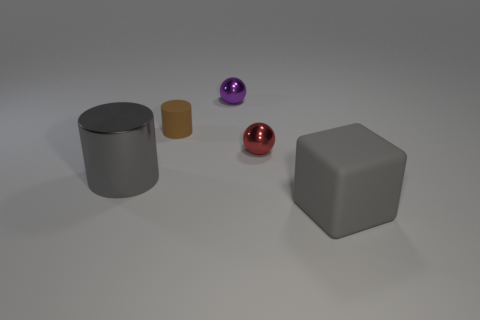What number of objects are either tiny brown rubber cylinders or objects that are in front of the small red ball?
Offer a terse response. 3. There is a matte thing in front of the matte cylinder; what is its size?
Make the answer very short. Large. There is a object that is the same color as the metal cylinder; what shape is it?
Make the answer very short. Cube. Is the material of the small brown thing the same as the large gray object that is on the right side of the red object?
Your answer should be very brief. Yes. There is a metallic object that is to the left of the sphere behind the small red metallic sphere; what number of gray matte blocks are in front of it?
Your answer should be compact. 1. What number of purple things are large metal objects or metallic balls?
Offer a very short reply. 1. There is a big object that is on the left side of the large gray block; what is its shape?
Make the answer very short. Cylinder. What is the color of the metal object that is the same size as the red shiny ball?
Make the answer very short. Purple. There is a small rubber object; does it have the same shape as the gray thing that is to the left of the brown rubber object?
Your answer should be compact. Yes. There is a big gray thing on the right side of the rubber thing that is behind the rubber thing that is in front of the metallic cylinder; what is its material?
Keep it short and to the point. Rubber. 